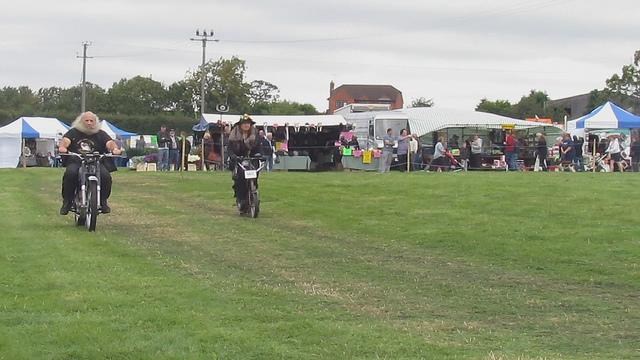What are they riding?
Concise answer only. Motorcycles. What are the men riding?
Give a very brief answer. Motorcycles. Is there more than one tent?
Give a very brief answer. Yes. Is this a race?
Be succinct. Yes. Is the horse in a competition?
Short answer required. No. 